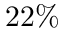<formula> <loc_0><loc_0><loc_500><loc_500>2 2 \%</formula> 